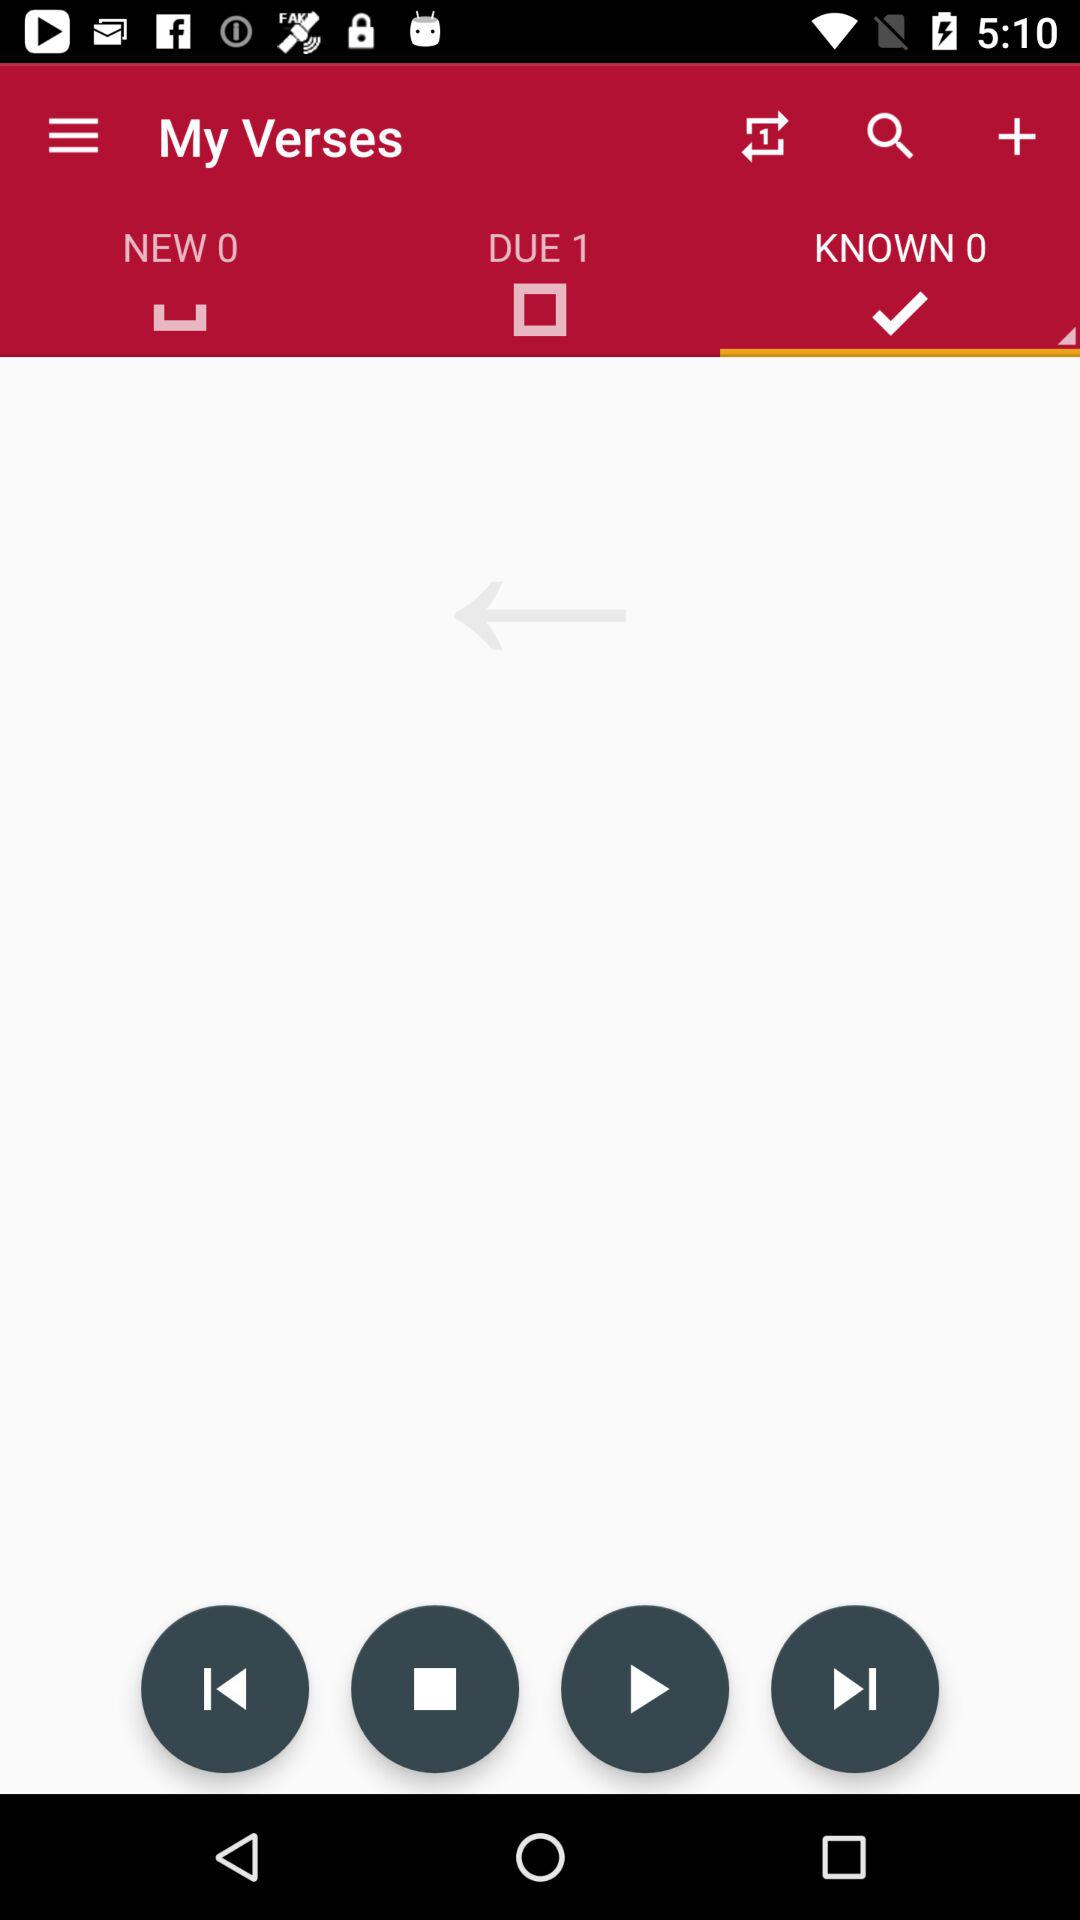What is the number count in "NEW"? The number count is 0. 